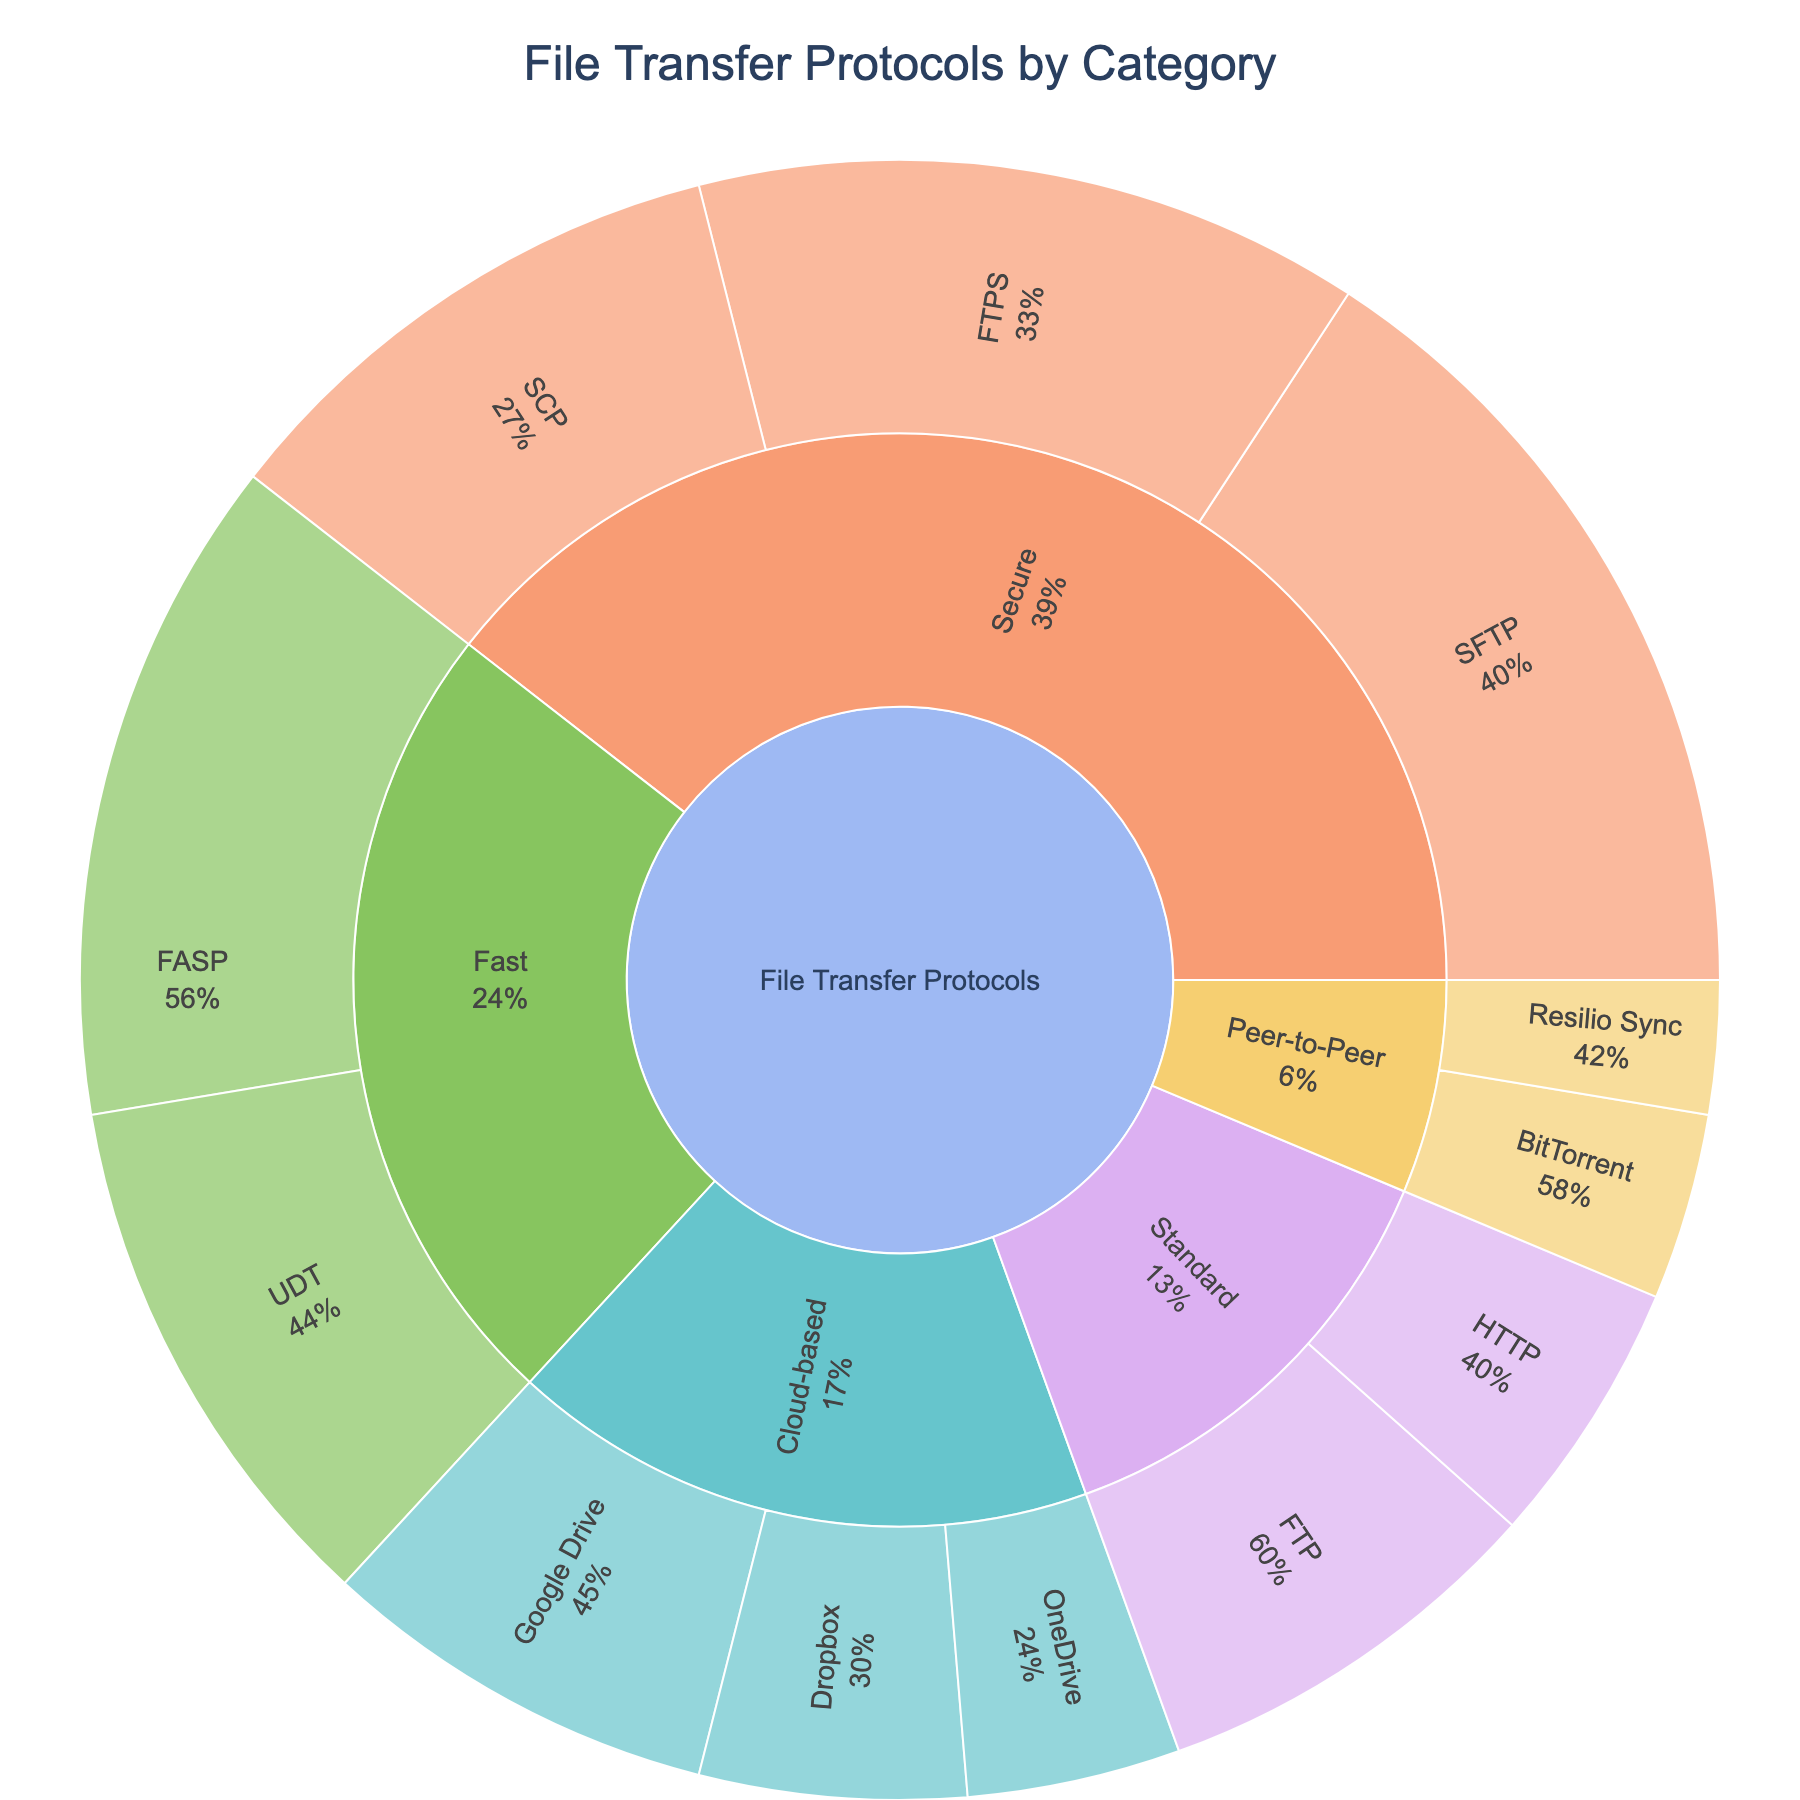What's the title of the sunburst plot? The title of the plot is typically centered at the top. In this case, it is clearly stated as "File Transfer Protocols by Category".
Answer: File Transfer Protocols by Category Which category has the highest value in the plot? By looking at the plot, you can see the size of the segments representing each category. The segment labeled "Secure" is the largest. This indicates it has the highest combined value.
Answer: Secure What is the total value for all Secure protocols? Add up the values of the Secure protocols. SFTP (30) + FTPS (25) + SCP (20) = 75
Answer: 75 How does SFTP compare to FTPS in terms of value? SFTP has a value of 30 and FTPS has a value of 25. Since 30 is greater than 25, SFTP has a higher value than FTPS.
Answer: SFTP has a higher value What percentage of the total value does the Peer-to-Peer category contribute? Add up the values of the Peer-to-Peer protocols: BitTorrent (7) + Resilio Sync (5) = 12. Then sum all the values in the plot: 30 + 25 + 20 + 15 + 10 + 25 + 20 + 15 + 10 + 8 + 7 + 5 = 190. The percentage contribution is (12 / 190) * 100 ≈ 6.3%.
Answer: Approximately 6.3% Combine the values of all Cloud-based protocols. What is the result? Add up the values of the Cloud-based protocols. Google Drive (15) + Dropbox (10) + OneDrive (8) = 33
Answer: 33 Which category has the smallest total value? Look at the segments labeled with each category. The smallest segment represents "Peer-to-Peer". Its total value is 12, which is less than any other category's total.
Answer: Peer-to-Peer How many subcategories are there within the Fast category? The "Fast" category includes FASP and UDT, which are two subcategories.
Answer: 2 What is the difference in value between FTP and HTTP subcategories under Standard protocols? Subtract the value of HTTP from the value of FTP. FTP (15) - HTTP (10) = 5
Answer: 5 In terms of security, what is the combined value of all Standard and Secure protocols? Add the total values of Standard and Secure protocols. Secure: 75, Standard: FTP (15) + HTTP (10) = 25. Combined: 75 + 25 = 100
Answer: 100 